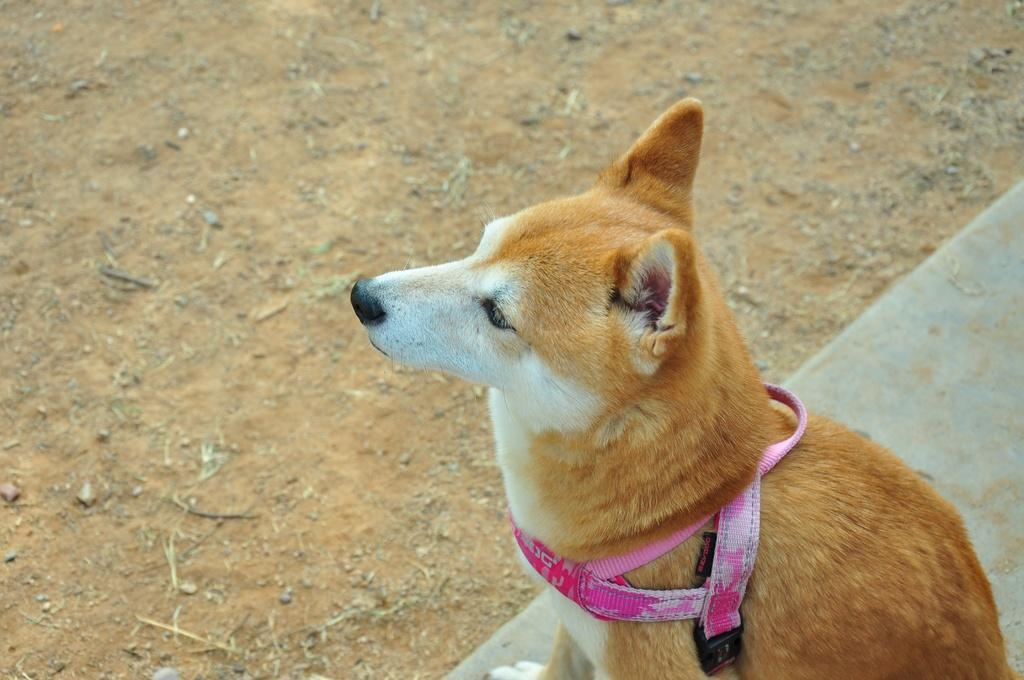What type of animal is in the image? There is a dog in the image. What is the dog wearing? The dog is wearing a belt. What is the dog standing on? The dog is on a surface. What can be seen in the background of the image? There is ground visible in the background of the image. What type of root can be seen growing in the image? There is no root visible in the image; it features a dog wearing a belt and standing on a surface. 